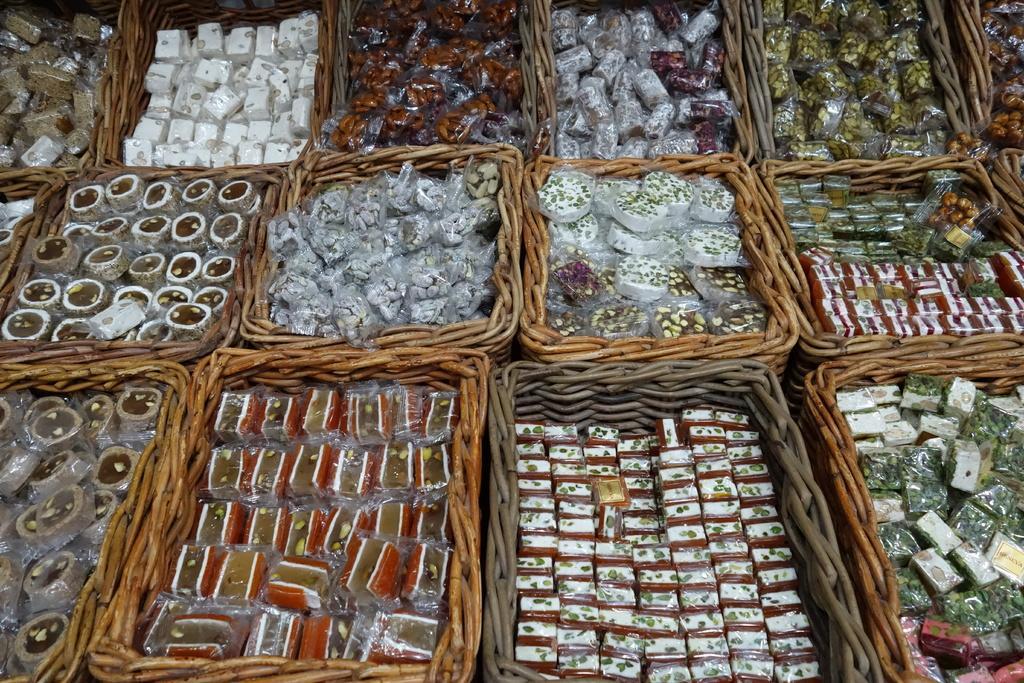In one or two sentences, can you explain what this image depicts? In this image, we can see some wooden boxes, in that boxes there are some sweets kept. 